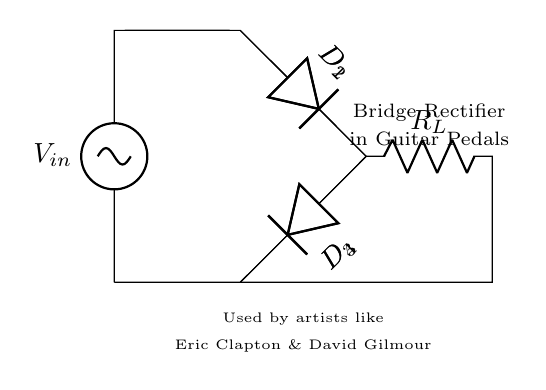What is the input voltage of the bridge rectifier circuit? The input voltage is labeled as V_in in the circuit diagram. It represents the voltage supplied to the rectifier setup.
Answer: V_in How many diodes are used in this circuit? The circuit shows a total of four diodes labeled D_1, D_2, D_3, and D_4, which are typically used in a bridge rectifier configuration.
Answer: 4 What is the function of the resistive component in this circuit? The resistor labeled R_L serves as the load resistance, providing a path for the current to flow after rectification has occurred, which is instrumental in functional applications such as guitar effect pedals.
Answer: Load Who are the famous artists mentioned in this circuit diagram? The circuit diagram mentions Eric Clapton and David Gilmour, indicating that this bridge rectifier is known to be used in equipment associated with them.
Answer: Eric Clapton & David Gilmour How is the bridge rectifier configured in terms of diode arrangement? The circuit diagram shows the diodes arranged in a bridge configuration, where two diodes conduct during each half of the AC input waveform, allowing for full-wave rectification.
Answer: Bridge configuration What type of rectification does this circuit perform? This circuit performs full-wave rectification, allowing both halves of the AC waveform to be utilized, which results in a smoother output voltage compared to half-wave rectification.
Answer: Full-wave What does the notation R_L signify in this context? The notation R_L signifies the load resistor in the circuit, which is essential for the practical application of the rectified output in devices such as guitar effect pedals.
Answer: Load resistor 